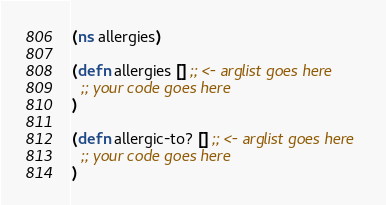Convert code to text. <code><loc_0><loc_0><loc_500><loc_500><_Clojure_>(ns allergies)

(defn allergies [] ;; <- arglist goes here
  ;; your code goes here
)

(defn allergic-to? [] ;; <- arglist goes here
  ;; your code goes here
)
</code> 